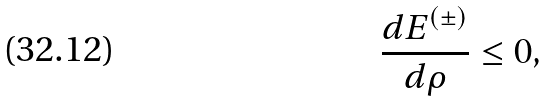Convert formula to latex. <formula><loc_0><loc_0><loc_500><loc_500>\frac { d E ^ { ( \pm ) } } { d \rho } \leq 0 ,</formula> 